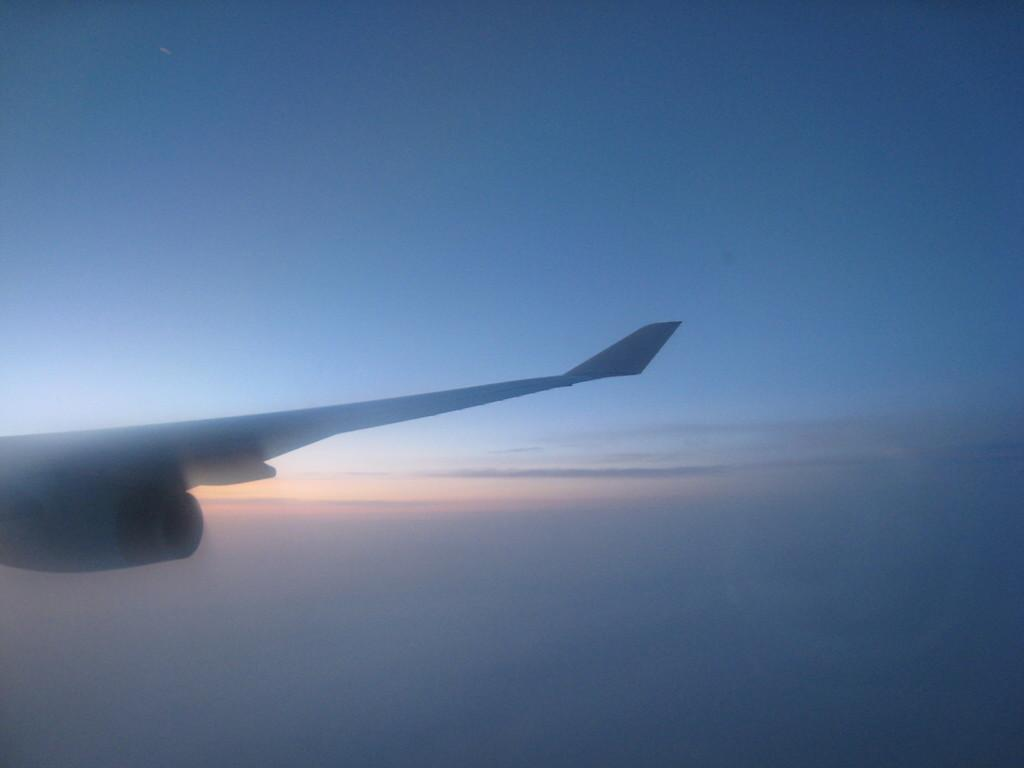What is the main subject of the image? The main subject of the image is a flight wind. What color is the background of the image? The background of the image is blue. What song is being sung in the background of the image? There is no song being sung in the image, as it features a flight wind and a blue background. 